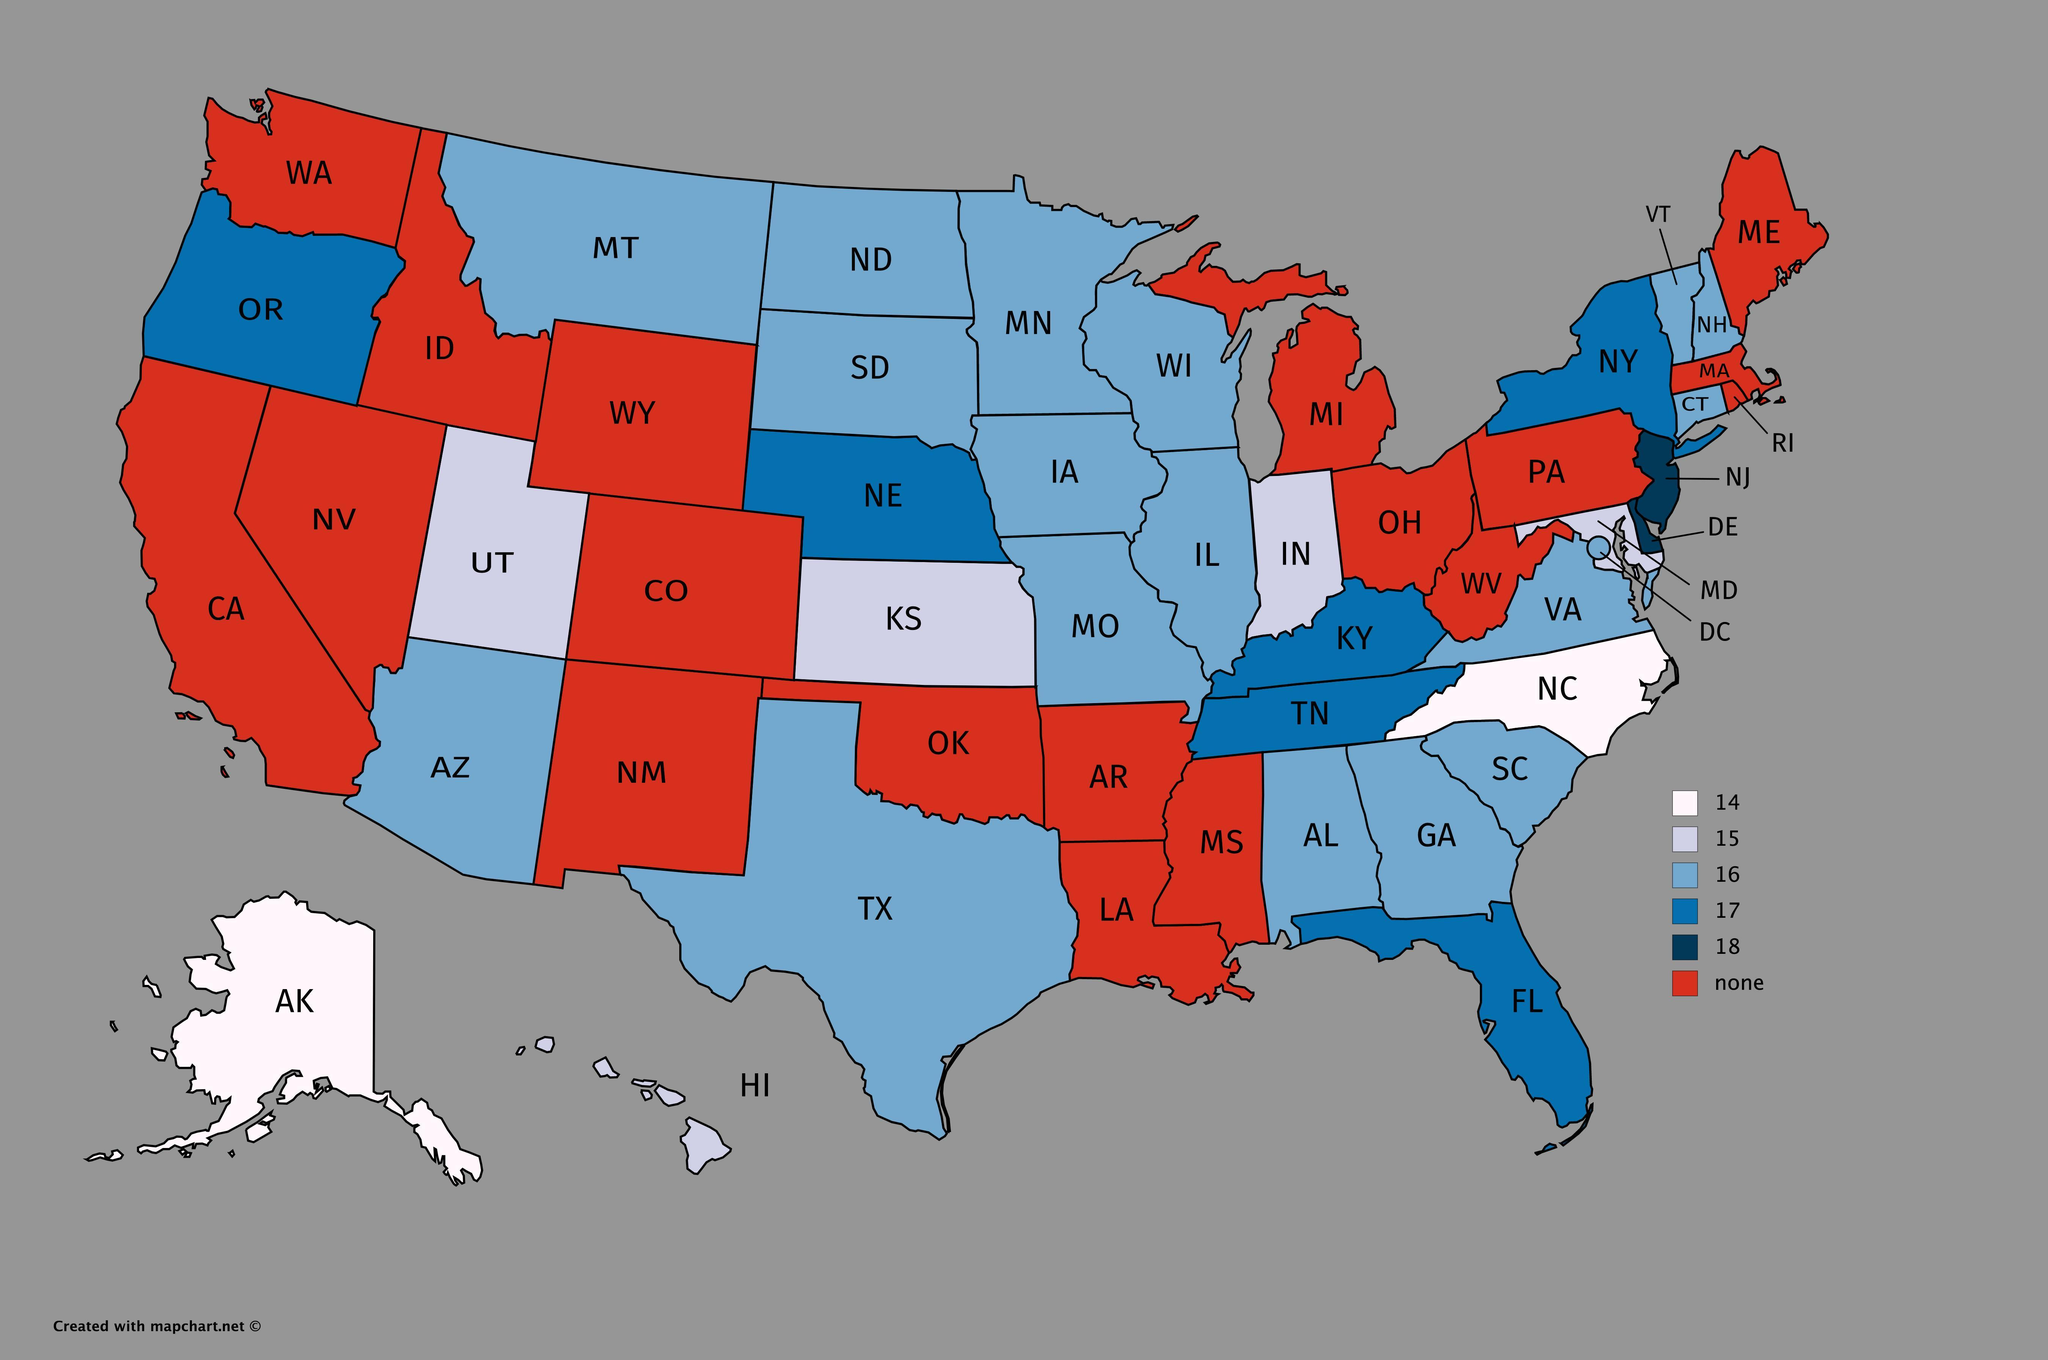How many states are given on the map?
Answer the question with a short phrase. 50 